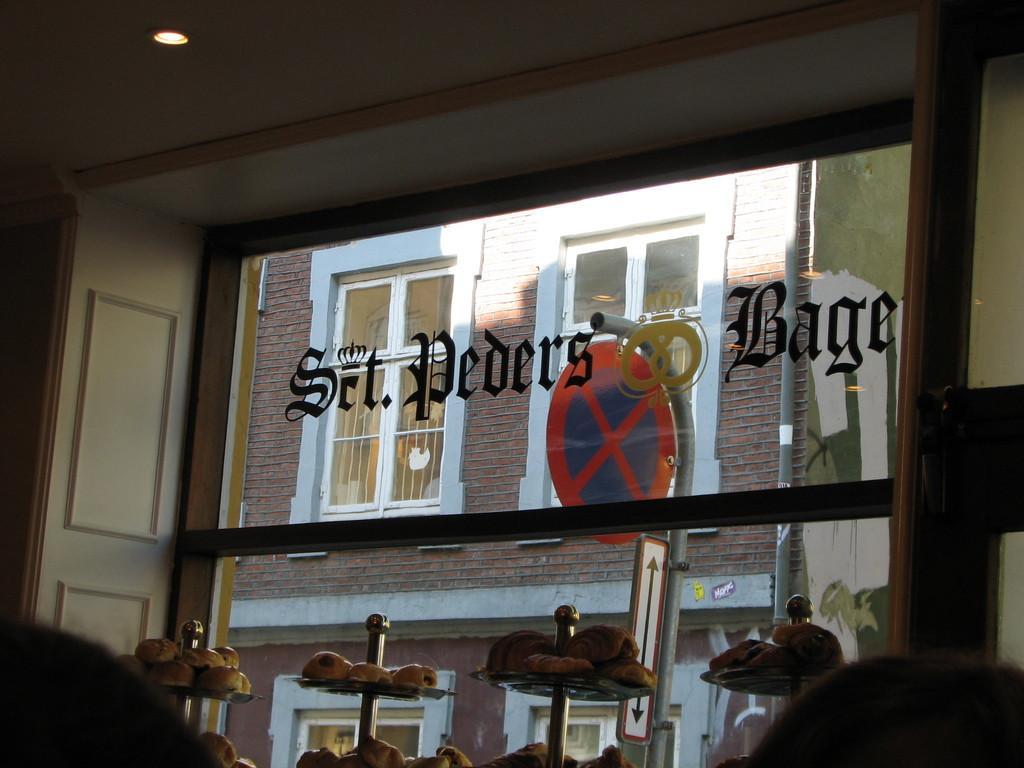Can you describe this image briefly? In this image in front there are people. There are food items on the plates. There is a glass window with some text on it. Through the glass window we can see the wall, glass windows. On top of the image there is a light. 